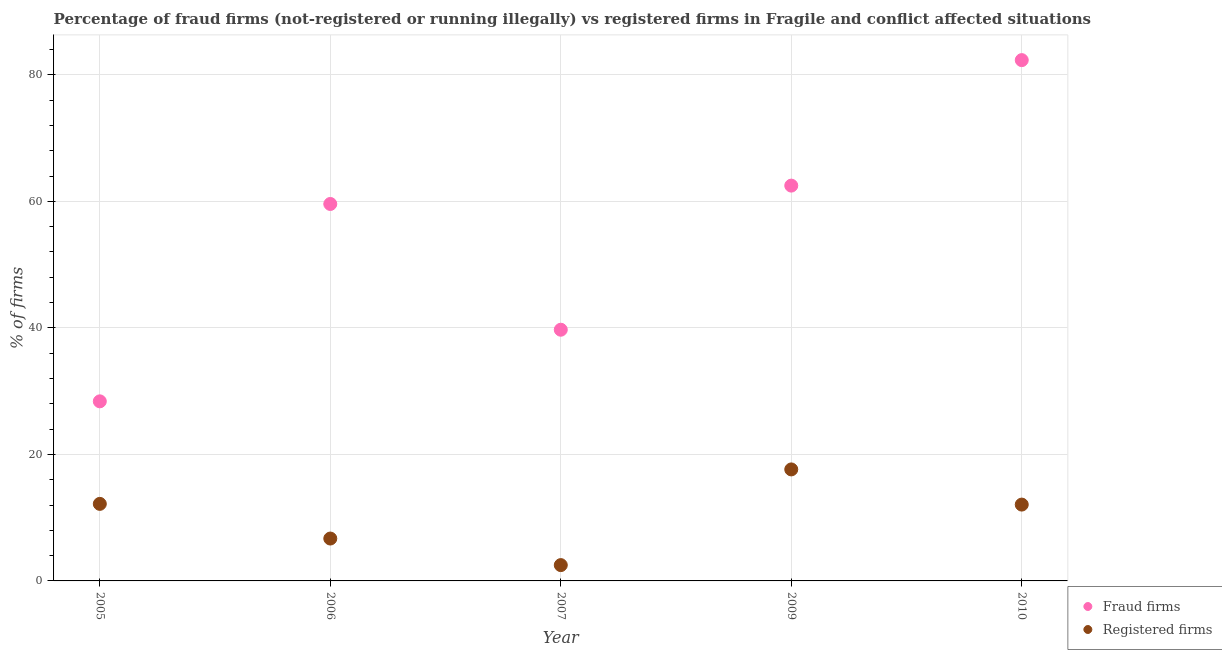What is the percentage of fraud firms in 2007?
Make the answer very short. 39.71. Across all years, what is the maximum percentage of fraud firms?
Provide a short and direct response. 82.33. Across all years, what is the minimum percentage of fraud firms?
Ensure brevity in your answer.  28.39. What is the total percentage of registered firms in the graph?
Make the answer very short. 51.07. What is the difference between the percentage of registered firms in 2005 and that in 2007?
Give a very brief answer. 9.68. What is the difference between the percentage of fraud firms in 2010 and the percentage of registered firms in 2009?
Offer a terse response. 64.7. What is the average percentage of fraud firms per year?
Keep it short and to the point. 54.5. In the year 2007, what is the difference between the percentage of fraud firms and percentage of registered firms?
Offer a very short reply. 37.21. In how many years, is the percentage of fraud firms greater than 16 %?
Give a very brief answer. 5. What is the ratio of the percentage of fraud firms in 2005 to that in 2010?
Your answer should be compact. 0.34. Is the percentage of fraud firms in 2007 less than that in 2009?
Give a very brief answer. Yes. Is the difference between the percentage of fraud firms in 2007 and 2010 greater than the difference between the percentage of registered firms in 2007 and 2010?
Offer a very short reply. No. What is the difference between the highest and the second highest percentage of registered firms?
Ensure brevity in your answer.  5.45. What is the difference between the highest and the lowest percentage of fraud firms?
Your answer should be compact. 53.94. In how many years, is the percentage of registered firms greater than the average percentage of registered firms taken over all years?
Make the answer very short. 3. Is the sum of the percentage of registered firms in 2005 and 2010 greater than the maximum percentage of fraud firms across all years?
Your answer should be compact. No. Is the percentage of registered firms strictly less than the percentage of fraud firms over the years?
Provide a short and direct response. Yes. How many years are there in the graph?
Ensure brevity in your answer.  5. Does the graph contain any zero values?
Offer a terse response. No. Does the graph contain grids?
Your response must be concise. Yes. Where does the legend appear in the graph?
Provide a succinct answer. Bottom right. How many legend labels are there?
Your answer should be very brief. 2. How are the legend labels stacked?
Make the answer very short. Vertical. What is the title of the graph?
Your response must be concise. Percentage of fraud firms (not-registered or running illegally) vs registered firms in Fragile and conflict affected situations. Does "Male" appear as one of the legend labels in the graph?
Provide a succinct answer. No. What is the label or title of the Y-axis?
Keep it short and to the point. % of firms. What is the % of firms of Fraud firms in 2005?
Make the answer very short. 28.39. What is the % of firms of Registered firms in 2005?
Your answer should be compact. 12.18. What is the % of firms in Fraud firms in 2006?
Provide a succinct answer. 59.59. What is the % of firms of Registered firms in 2006?
Keep it short and to the point. 6.7. What is the % of firms of Fraud firms in 2007?
Give a very brief answer. 39.71. What is the % of firms in Registered firms in 2007?
Offer a terse response. 2.5. What is the % of firms of Fraud firms in 2009?
Offer a very short reply. 62.49. What is the % of firms of Registered firms in 2009?
Your answer should be compact. 17.63. What is the % of firms in Fraud firms in 2010?
Offer a very short reply. 82.33. What is the % of firms in Registered firms in 2010?
Offer a terse response. 12.07. Across all years, what is the maximum % of firms of Fraud firms?
Offer a terse response. 82.33. Across all years, what is the maximum % of firms of Registered firms?
Offer a terse response. 17.63. Across all years, what is the minimum % of firms in Fraud firms?
Offer a terse response. 28.39. What is the total % of firms of Fraud firms in the graph?
Provide a short and direct response. 272.51. What is the total % of firms of Registered firms in the graph?
Offer a terse response. 51.07. What is the difference between the % of firms of Fraud firms in 2005 and that in 2006?
Give a very brief answer. -31.2. What is the difference between the % of firms of Registered firms in 2005 and that in 2006?
Offer a terse response. 5.48. What is the difference between the % of firms of Fraud firms in 2005 and that in 2007?
Ensure brevity in your answer.  -11.32. What is the difference between the % of firms of Registered firms in 2005 and that in 2007?
Your answer should be very brief. 9.68. What is the difference between the % of firms in Fraud firms in 2005 and that in 2009?
Your answer should be very brief. -34.1. What is the difference between the % of firms in Registered firms in 2005 and that in 2009?
Give a very brief answer. -5.45. What is the difference between the % of firms of Fraud firms in 2005 and that in 2010?
Your answer should be very brief. -53.94. What is the difference between the % of firms of Registered firms in 2005 and that in 2010?
Keep it short and to the point. 0.11. What is the difference between the % of firms in Fraud firms in 2006 and that in 2007?
Your answer should be very brief. 19.88. What is the difference between the % of firms of Fraud firms in 2006 and that in 2009?
Provide a short and direct response. -2.9. What is the difference between the % of firms in Registered firms in 2006 and that in 2009?
Your answer should be very brief. -10.93. What is the difference between the % of firms in Fraud firms in 2006 and that in 2010?
Provide a short and direct response. -22.74. What is the difference between the % of firms of Registered firms in 2006 and that in 2010?
Give a very brief answer. -5.37. What is the difference between the % of firms of Fraud firms in 2007 and that in 2009?
Your answer should be very brief. -22.78. What is the difference between the % of firms in Registered firms in 2007 and that in 2009?
Your answer should be very brief. -15.13. What is the difference between the % of firms of Fraud firms in 2007 and that in 2010?
Keep it short and to the point. -42.62. What is the difference between the % of firms in Registered firms in 2007 and that in 2010?
Keep it short and to the point. -9.57. What is the difference between the % of firms in Fraud firms in 2009 and that in 2010?
Offer a very short reply. -19.84. What is the difference between the % of firms of Registered firms in 2009 and that in 2010?
Make the answer very short. 5.56. What is the difference between the % of firms in Fraud firms in 2005 and the % of firms in Registered firms in 2006?
Make the answer very short. 21.69. What is the difference between the % of firms of Fraud firms in 2005 and the % of firms of Registered firms in 2007?
Give a very brief answer. 25.89. What is the difference between the % of firms in Fraud firms in 2005 and the % of firms in Registered firms in 2009?
Your answer should be compact. 10.76. What is the difference between the % of firms of Fraud firms in 2005 and the % of firms of Registered firms in 2010?
Keep it short and to the point. 16.32. What is the difference between the % of firms in Fraud firms in 2006 and the % of firms in Registered firms in 2007?
Ensure brevity in your answer.  57.09. What is the difference between the % of firms in Fraud firms in 2006 and the % of firms in Registered firms in 2009?
Make the answer very short. 41.96. What is the difference between the % of firms in Fraud firms in 2006 and the % of firms in Registered firms in 2010?
Your response must be concise. 47.52. What is the difference between the % of firms in Fraud firms in 2007 and the % of firms in Registered firms in 2009?
Your answer should be compact. 22.08. What is the difference between the % of firms in Fraud firms in 2007 and the % of firms in Registered firms in 2010?
Keep it short and to the point. 27.64. What is the difference between the % of firms in Fraud firms in 2009 and the % of firms in Registered firms in 2010?
Offer a very short reply. 50.42. What is the average % of firms in Fraud firms per year?
Give a very brief answer. 54.5. What is the average % of firms in Registered firms per year?
Keep it short and to the point. 10.21. In the year 2005, what is the difference between the % of firms of Fraud firms and % of firms of Registered firms?
Offer a very short reply. 16.21. In the year 2006, what is the difference between the % of firms in Fraud firms and % of firms in Registered firms?
Your answer should be compact. 52.89. In the year 2007, what is the difference between the % of firms of Fraud firms and % of firms of Registered firms?
Offer a very short reply. 37.21. In the year 2009, what is the difference between the % of firms of Fraud firms and % of firms of Registered firms?
Your answer should be very brief. 44.86. In the year 2010, what is the difference between the % of firms in Fraud firms and % of firms in Registered firms?
Keep it short and to the point. 70.26. What is the ratio of the % of firms of Fraud firms in 2005 to that in 2006?
Provide a succinct answer. 0.48. What is the ratio of the % of firms in Registered firms in 2005 to that in 2006?
Make the answer very short. 1.82. What is the ratio of the % of firms in Fraud firms in 2005 to that in 2007?
Ensure brevity in your answer.  0.71. What is the ratio of the % of firms in Registered firms in 2005 to that in 2007?
Your response must be concise. 4.87. What is the ratio of the % of firms of Fraud firms in 2005 to that in 2009?
Make the answer very short. 0.45. What is the ratio of the % of firms of Registered firms in 2005 to that in 2009?
Offer a terse response. 0.69. What is the ratio of the % of firms in Fraud firms in 2005 to that in 2010?
Provide a succinct answer. 0.34. What is the ratio of the % of firms of Registered firms in 2005 to that in 2010?
Provide a succinct answer. 1.01. What is the ratio of the % of firms in Fraud firms in 2006 to that in 2007?
Your response must be concise. 1.5. What is the ratio of the % of firms in Registered firms in 2006 to that in 2007?
Your answer should be compact. 2.68. What is the ratio of the % of firms in Fraud firms in 2006 to that in 2009?
Provide a succinct answer. 0.95. What is the ratio of the % of firms of Registered firms in 2006 to that in 2009?
Offer a terse response. 0.38. What is the ratio of the % of firms in Fraud firms in 2006 to that in 2010?
Your response must be concise. 0.72. What is the ratio of the % of firms in Registered firms in 2006 to that in 2010?
Keep it short and to the point. 0.56. What is the ratio of the % of firms in Fraud firms in 2007 to that in 2009?
Your answer should be very brief. 0.64. What is the ratio of the % of firms of Registered firms in 2007 to that in 2009?
Provide a succinct answer. 0.14. What is the ratio of the % of firms of Fraud firms in 2007 to that in 2010?
Provide a short and direct response. 0.48. What is the ratio of the % of firms of Registered firms in 2007 to that in 2010?
Make the answer very short. 0.21. What is the ratio of the % of firms in Fraud firms in 2009 to that in 2010?
Keep it short and to the point. 0.76. What is the ratio of the % of firms of Registered firms in 2009 to that in 2010?
Offer a very short reply. 1.46. What is the difference between the highest and the second highest % of firms in Fraud firms?
Your response must be concise. 19.84. What is the difference between the highest and the second highest % of firms of Registered firms?
Keep it short and to the point. 5.45. What is the difference between the highest and the lowest % of firms of Fraud firms?
Provide a succinct answer. 53.94. What is the difference between the highest and the lowest % of firms in Registered firms?
Offer a terse response. 15.13. 